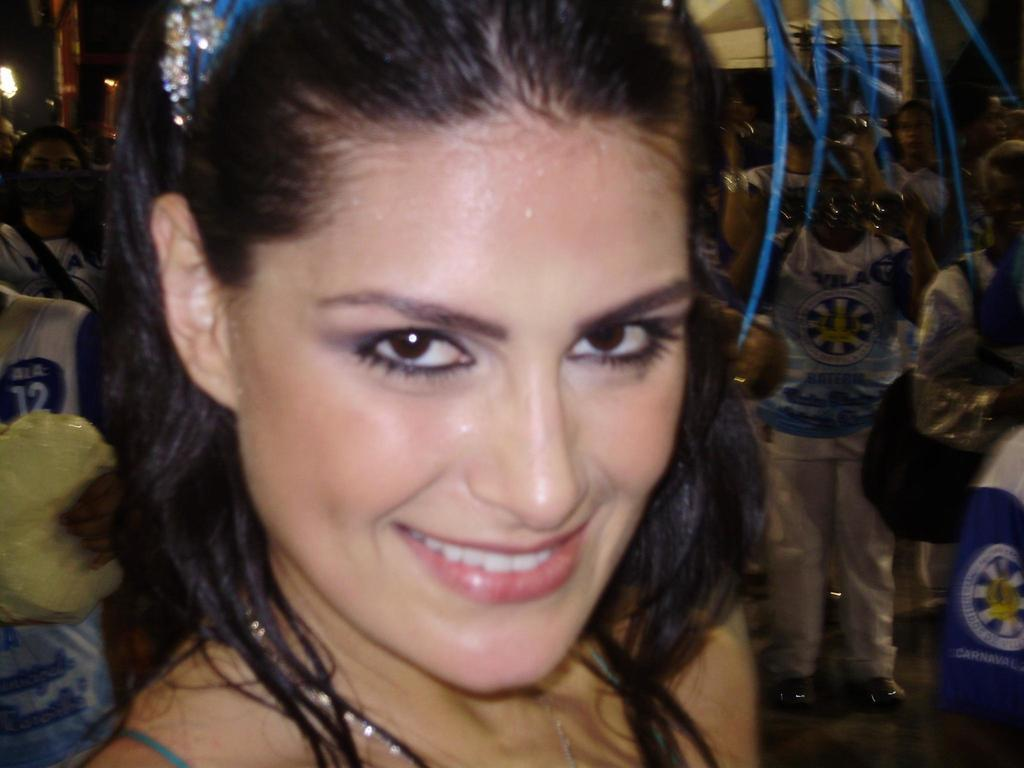Who is present in the image? There is a woman in the image. What is the woman's facial expression? The woman is smiling. Can you describe the background of the image? There are people in the background of the image. Where is the light source located in the image? There is a light on the left side of the image. What type of pie is the woman holding in the image? There is no pie present in the image; the woman is not holding anything. 